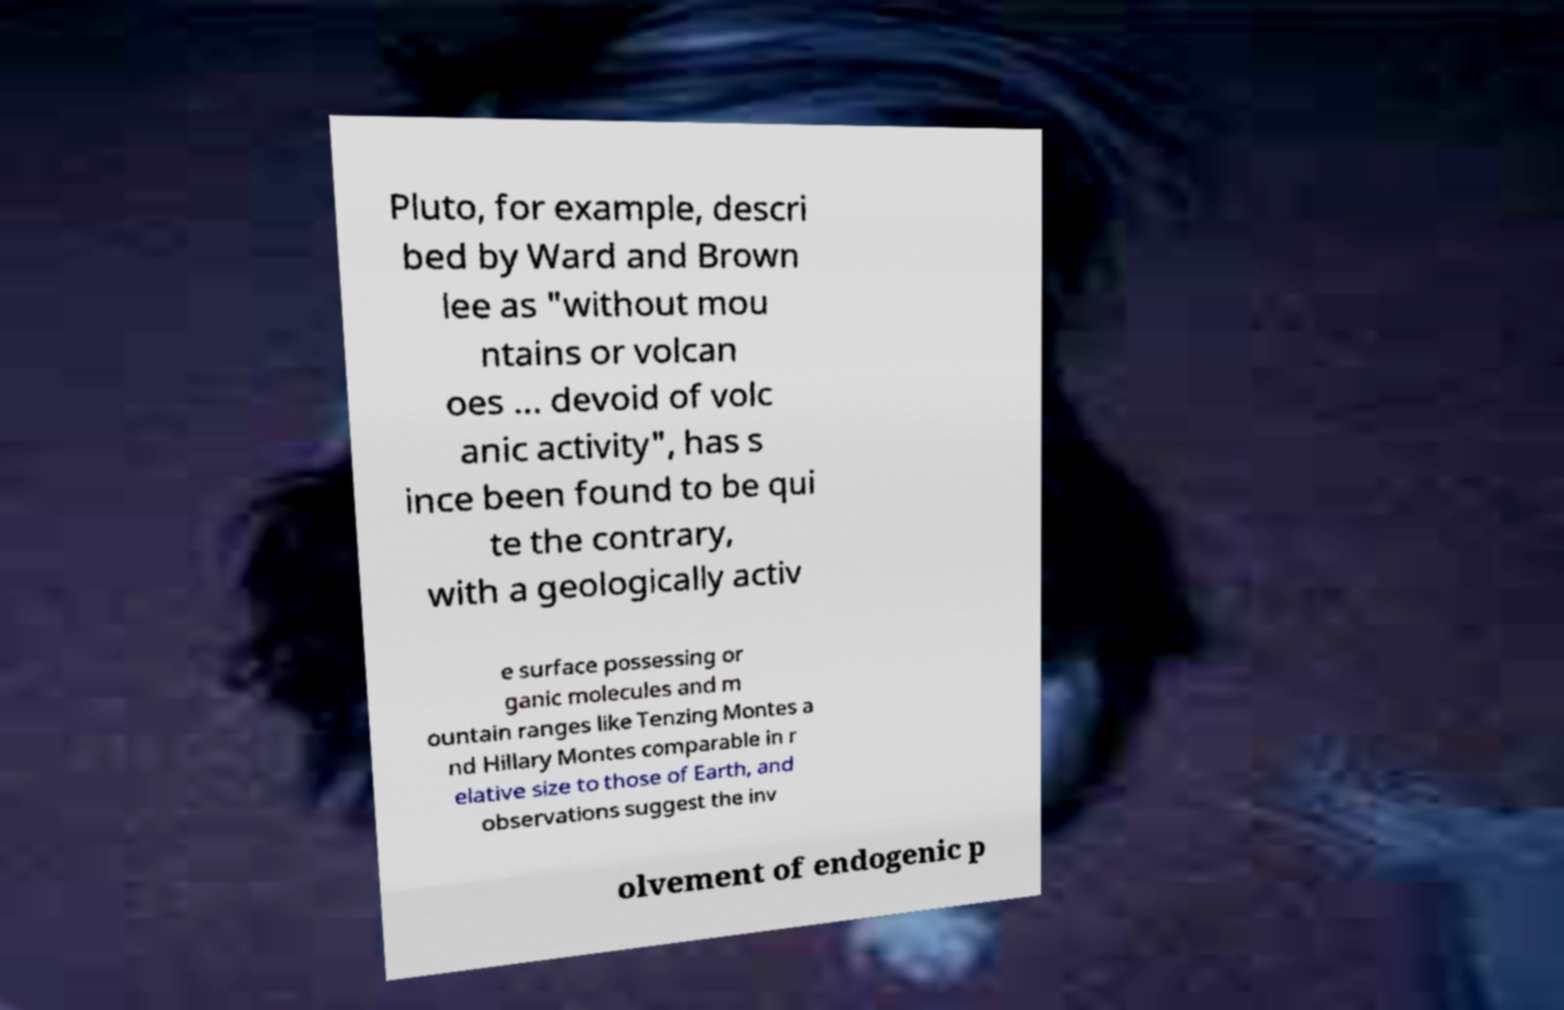Could you extract and type out the text from this image? Pluto, for example, descri bed by Ward and Brown lee as "without mou ntains or volcan oes ... devoid of volc anic activity", has s ince been found to be qui te the contrary, with a geologically activ e surface possessing or ganic molecules and m ountain ranges like Tenzing Montes a nd Hillary Montes comparable in r elative size to those of Earth, and observations suggest the inv olvement of endogenic p 